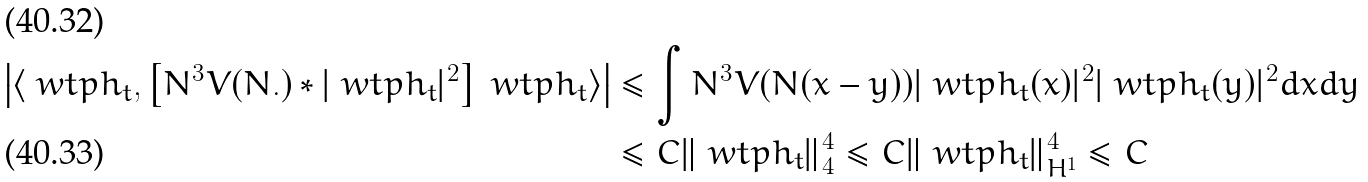<formula> <loc_0><loc_0><loc_500><loc_500>\left | \langle \ w t p h _ { t } , \left [ N ^ { 3 } V ( N . ) * | \ w t p h _ { t } | ^ { 2 } \right ] \ w t p h _ { t } \rangle \right | & \leq \int N ^ { 3 } V ( N ( x - y ) ) | \ w t p h _ { t } ( x ) | ^ { 2 } | \ w t p h _ { t } ( y ) | ^ { 2 } d x d y \\ & \leq C \| \ w t p h _ { t } \| _ { 4 } ^ { 4 } \leq C \| \ w t p h _ { t } \| _ { H ^ { 1 } } ^ { 4 } \leq C</formula> 